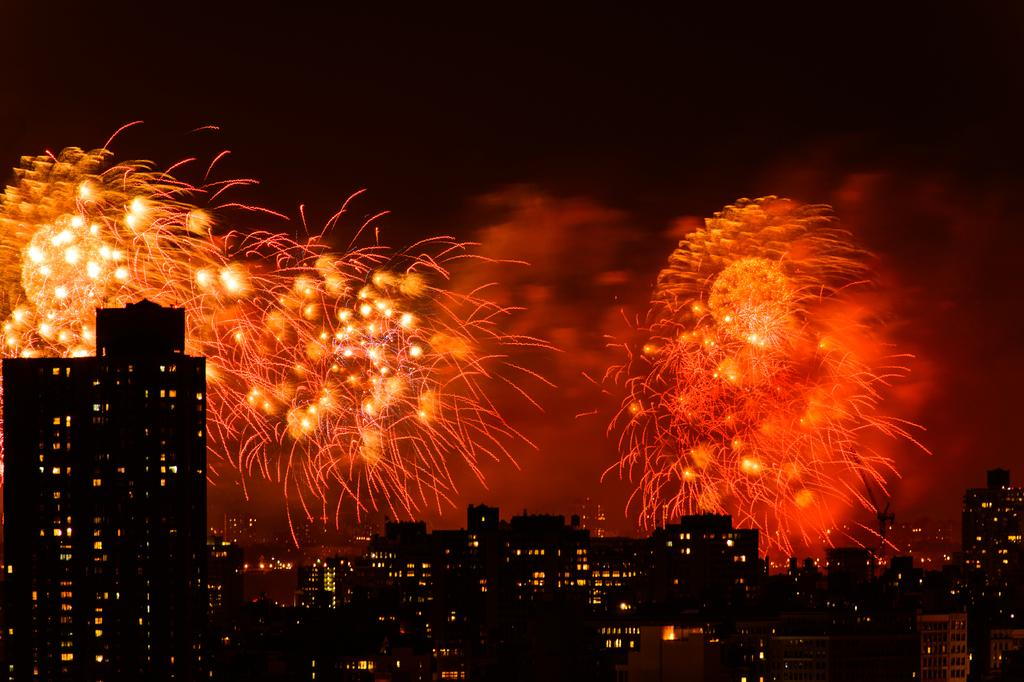What type of structures can be seen in the image? There are buildings in the image. Can you describe something unusual in the sky? Yes, there are crackers visible in the sky. What type of cork is being used to hold the buildings together in the image? There is no cork present in the image, and the buildings are not held together by any such material. 